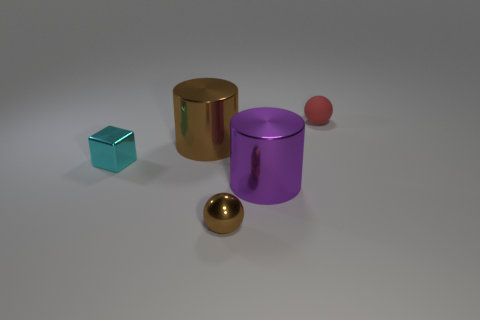The other tiny thing that is the same shape as the small matte thing is what color?
Your answer should be very brief. Brown. Are there any other big purple metal things that have the same shape as the purple object?
Give a very brief answer. No. What number of things are either tiny red objects or tiny things in front of the big brown cylinder?
Make the answer very short. 3. What is the color of the large metallic object to the right of the large brown thing?
Your answer should be very brief. Purple. There is a shiny cylinder on the left side of the purple shiny thing; is it the same size as the metal cylinder to the right of the small metallic sphere?
Make the answer very short. Yes. Are there any blocks that have the same size as the red rubber object?
Give a very brief answer. Yes. There is a tiny ball behind the tiny cyan cube; how many big brown things are in front of it?
Ensure brevity in your answer.  1. What is the material of the purple thing?
Provide a succinct answer. Metal. How many big metal objects are in front of the big purple object?
Provide a short and direct response. 0. What number of metal spheres are the same color as the small metal block?
Your response must be concise. 0. 